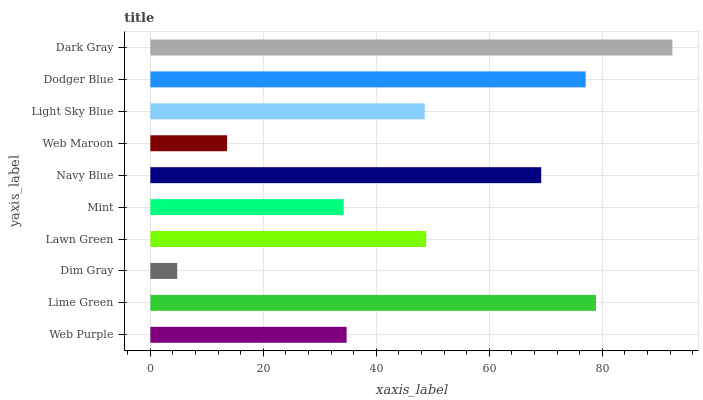Is Dim Gray the minimum?
Answer yes or no. Yes. Is Dark Gray the maximum?
Answer yes or no. Yes. Is Lime Green the minimum?
Answer yes or no. No. Is Lime Green the maximum?
Answer yes or no. No. Is Lime Green greater than Web Purple?
Answer yes or no. Yes. Is Web Purple less than Lime Green?
Answer yes or no. Yes. Is Web Purple greater than Lime Green?
Answer yes or no. No. Is Lime Green less than Web Purple?
Answer yes or no. No. Is Lawn Green the high median?
Answer yes or no. Yes. Is Light Sky Blue the low median?
Answer yes or no. Yes. Is Dodger Blue the high median?
Answer yes or no. No. Is Mint the low median?
Answer yes or no. No. 